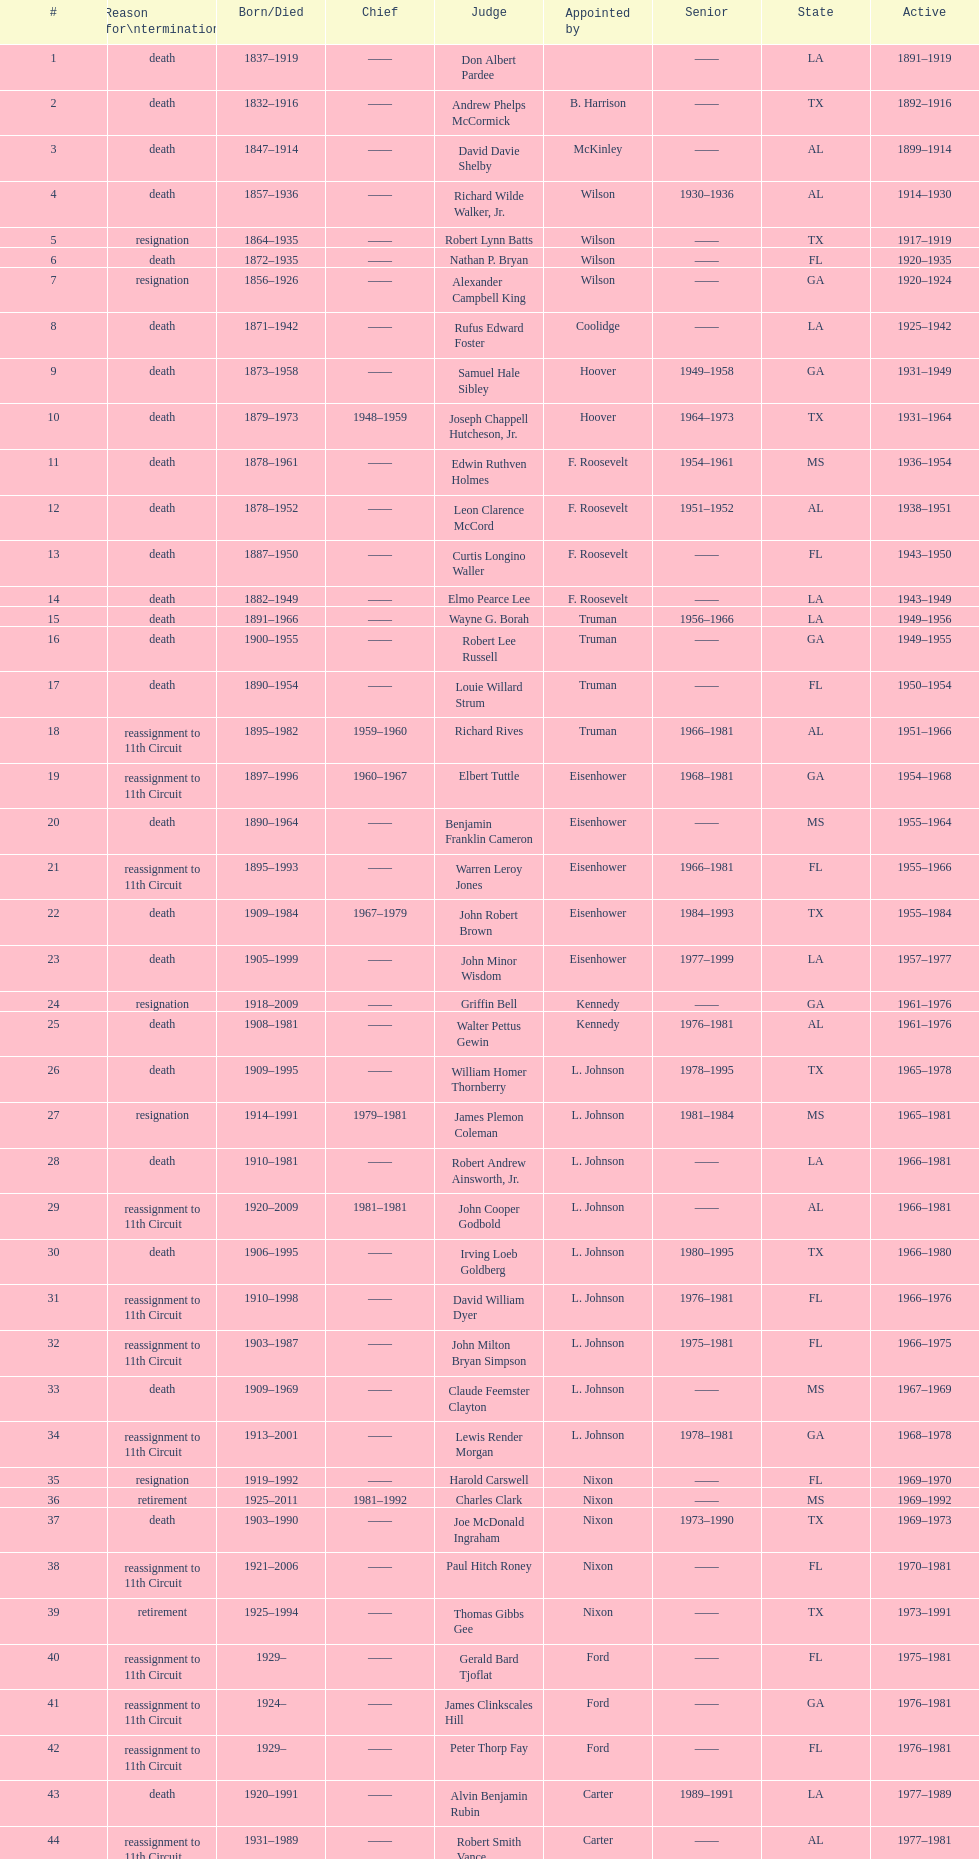Name a state listed at least 4 times. TX. 